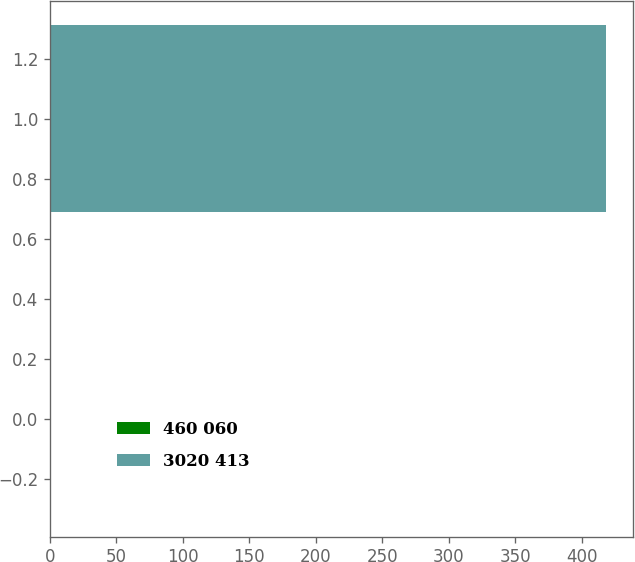Convert chart. <chart><loc_0><loc_0><loc_500><loc_500><bar_chart><fcel>460 060<fcel>3020 413<nl><fcel>0.6<fcel>418<nl></chart> 